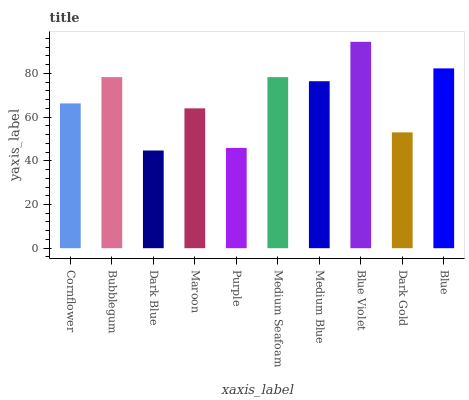Is Bubblegum the minimum?
Answer yes or no. No. Is Bubblegum the maximum?
Answer yes or no. No. Is Bubblegum greater than Cornflower?
Answer yes or no. Yes. Is Cornflower less than Bubblegum?
Answer yes or no. Yes. Is Cornflower greater than Bubblegum?
Answer yes or no. No. Is Bubblegum less than Cornflower?
Answer yes or no. No. Is Medium Blue the high median?
Answer yes or no. Yes. Is Cornflower the low median?
Answer yes or no. Yes. Is Blue the high median?
Answer yes or no. No. Is Medium Blue the low median?
Answer yes or no. No. 